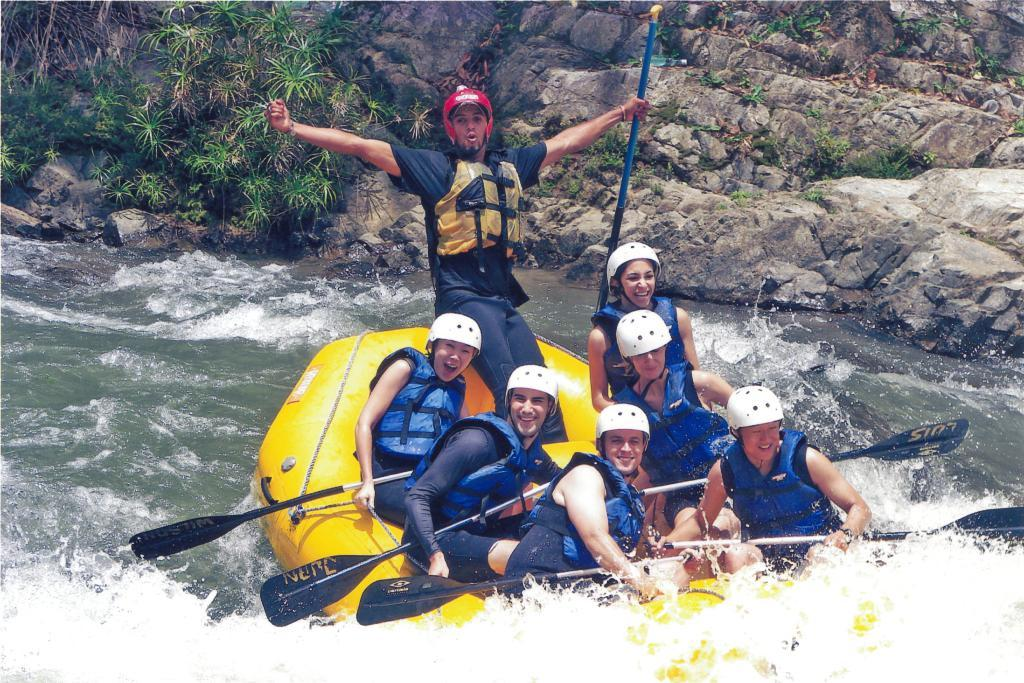Who is present in the image? There are people in the image. What are the people doing in the image? The people are sitting on a boat and participating in river rafting. What color is the cub's eye in the image? There is no cub present in the image, so it is not possible to answer that question. 